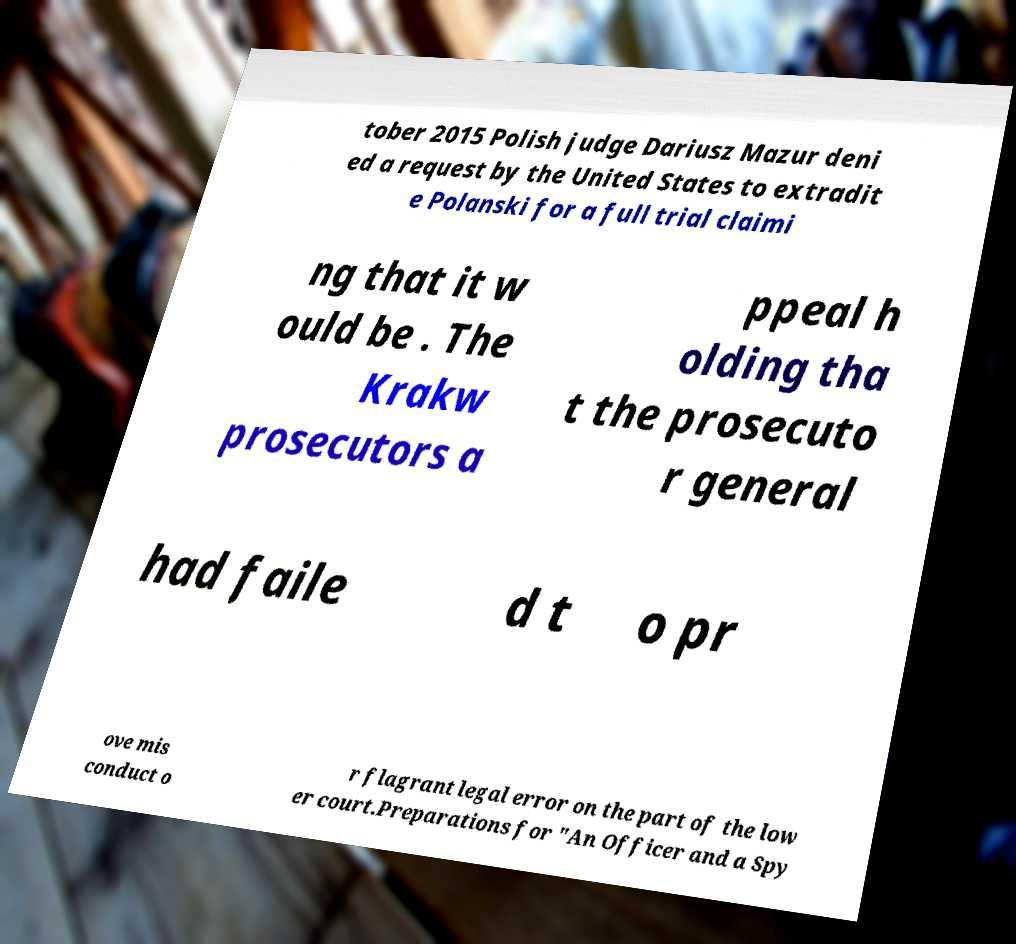Please read and relay the text visible in this image. What does it say? tober 2015 Polish judge Dariusz Mazur deni ed a request by the United States to extradit e Polanski for a full trial claimi ng that it w ould be . The Krakw prosecutors a ppeal h olding tha t the prosecuto r general had faile d t o pr ove mis conduct o r flagrant legal error on the part of the low er court.Preparations for "An Officer and a Spy 